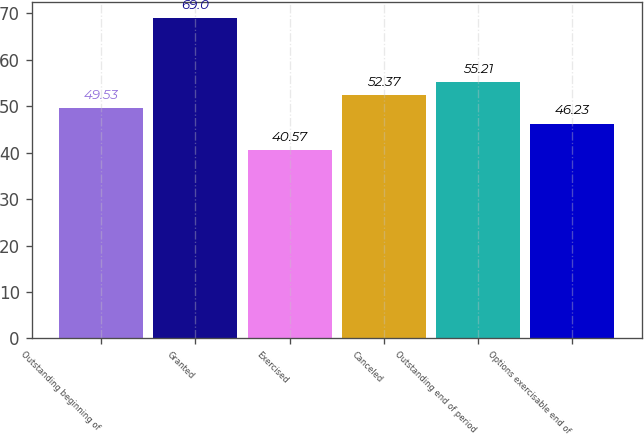Convert chart to OTSL. <chart><loc_0><loc_0><loc_500><loc_500><bar_chart><fcel>Outstanding beginning of<fcel>Granted<fcel>Exercised<fcel>Canceled<fcel>Outstanding end of period<fcel>Options exercisable end of<nl><fcel>49.53<fcel>69<fcel>40.57<fcel>52.37<fcel>55.21<fcel>46.23<nl></chart> 